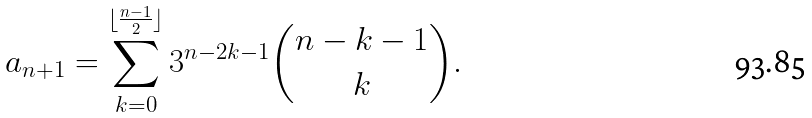Convert formula to latex. <formula><loc_0><loc_0><loc_500><loc_500>a _ { n + 1 } = \sum _ { k = 0 } ^ { \lfloor \frac { n - 1 } { 2 } \rfloor } 3 ^ { n - 2 k - 1 } { n - k - 1 \choose k } .</formula> 